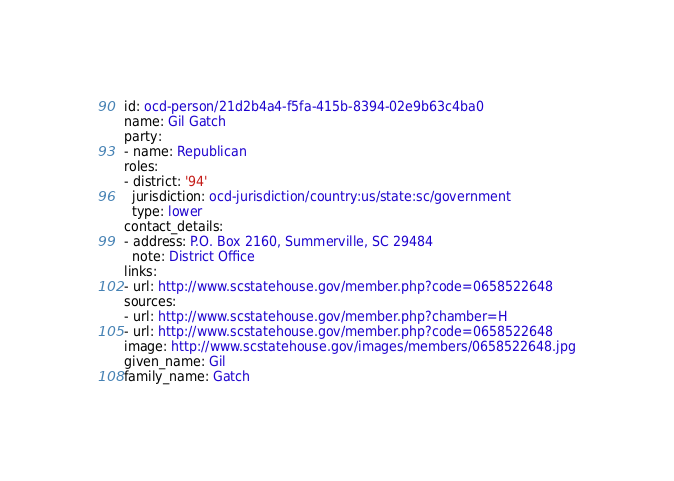<code> <loc_0><loc_0><loc_500><loc_500><_YAML_>id: ocd-person/21d2b4a4-f5fa-415b-8394-02e9b63c4ba0
name: Gil Gatch
party:
- name: Republican
roles:
- district: '94'
  jurisdiction: ocd-jurisdiction/country:us/state:sc/government
  type: lower
contact_details:
- address: P.O. Box 2160, Summerville, SC 29484
  note: District Office
links:
- url: http://www.scstatehouse.gov/member.php?code=0658522648
sources:
- url: http://www.scstatehouse.gov/member.php?chamber=H
- url: http://www.scstatehouse.gov/member.php?code=0658522648
image: http://www.scstatehouse.gov/images/members/0658522648.jpg
given_name: Gil
family_name: Gatch
</code> 